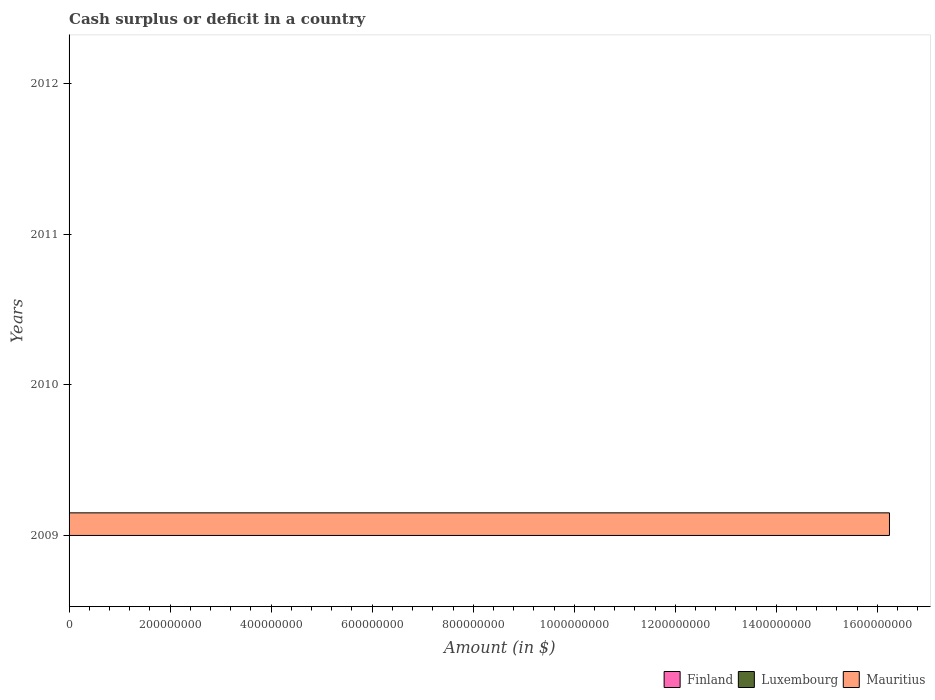How many different coloured bars are there?
Give a very brief answer. 1. Are the number of bars per tick equal to the number of legend labels?
Your answer should be compact. No. What is the label of the 2nd group of bars from the top?
Ensure brevity in your answer.  2011. In how many cases, is the number of bars for a given year not equal to the number of legend labels?
Offer a very short reply. 4. What is the amount of cash surplus or deficit in Luxembourg in 2009?
Provide a short and direct response. 0. Across all years, what is the maximum amount of cash surplus or deficit in Mauritius?
Give a very brief answer. 1.62e+09. Across all years, what is the minimum amount of cash surplus or deficit in Mauritius?
Offer a very short reply. 0. In which year was the amount of cash surplus or deficit in Mauritius maximum?
Your response must be concise. 2009. In how many years, is the amount of cash surplus or deficit in Luxembourg greater than 1280000000 $?
Ensure brevity in your answer.  0. What is the difference between the highest and the lowest amount of cash surplus or deficit in Mauritius?
Offer a very short reply. 1.62e+09. Is it the case that in every year, the sum of the amount of cash surplus or deficit in Finland and amount of cash surplus or deficit in Mauritius is greater than the amount of cash surplus or deficit in Luxembourg?
Offer a terse response. No. Are all the bars in the graph horizontal?
Provide a short and direct response. Yes. Does the graph contain grids?
Your answer should be very brief. No. Where does the legend appear in the graph?
Provide a succinct answer. Bottom right. What is the title of the graph?
Offer a very short reply. Cash surplus or deficit in a country. What is the label or title of the X-axis?
Provide a succinct answer. Amount (in $). What is the label or title of the Y-axis?
Offer a terse response. Years. What is the Amount (in $) in Mauritius in 2009?
Keep it short and to the point. 1.62e+09. What is the Amount (in $) of Mauritius in 2010?
Offer a very short reply. 0. What is the Amount (in $) in Finland in 2011?
Your answer should be very brief. 0. What is the Amount (in $) of Mauritius in 2011?
Your response must be concise. 0. What is the Amount (in $) of Finland in 2012?
Provide a succinct answer. 0. What is the Amount (in $) in Luxembourg in 2012?
Offer a very short reply. 0. What is the Amount (in $) of Mauritius in 2012?
Your answer should be compact. 0. Across all years, what is the maximum Amount (in $) of Mauritius?
Offer a very short reply. 1.62e+09. What is the total Amount (in $) of Finland in the graph?
Keep it short and to the point. 0. What is the total Amount (in $) of Luxembourg in the graph?
Make the answer very short. 0. What is the total Amount (in $) of Mauritius in the graph?
Your answer should be compact. 1.62e+09. What is the average Amount (in $) of Luxembourg per year?
Keep it short and to the point. 0. What is the average Amount (in $) in Mauritius per year?
Ensure brevity in your answer.  4.06e+08. What is the difference between the highest and the lowest Amount (in $) in Mauritius?
Your answer should be very brief. 1.62e+09. 